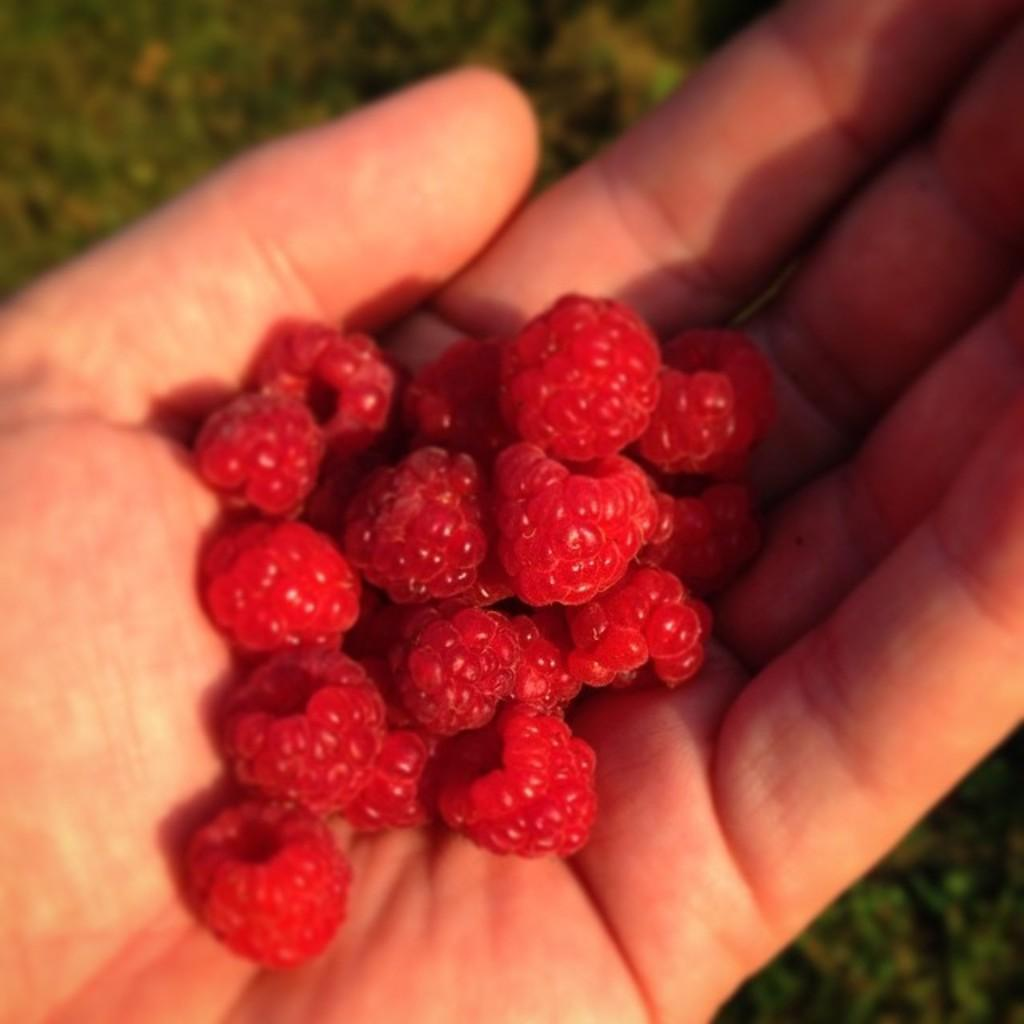What is visible in the image? There is a person's hand in the image. What is the hand holding? The hand is holding strawberries. What type of humor can be seen in the patch on the person's hand in the image? There is no patch or any indication of humor present on the person's hand in the image. 